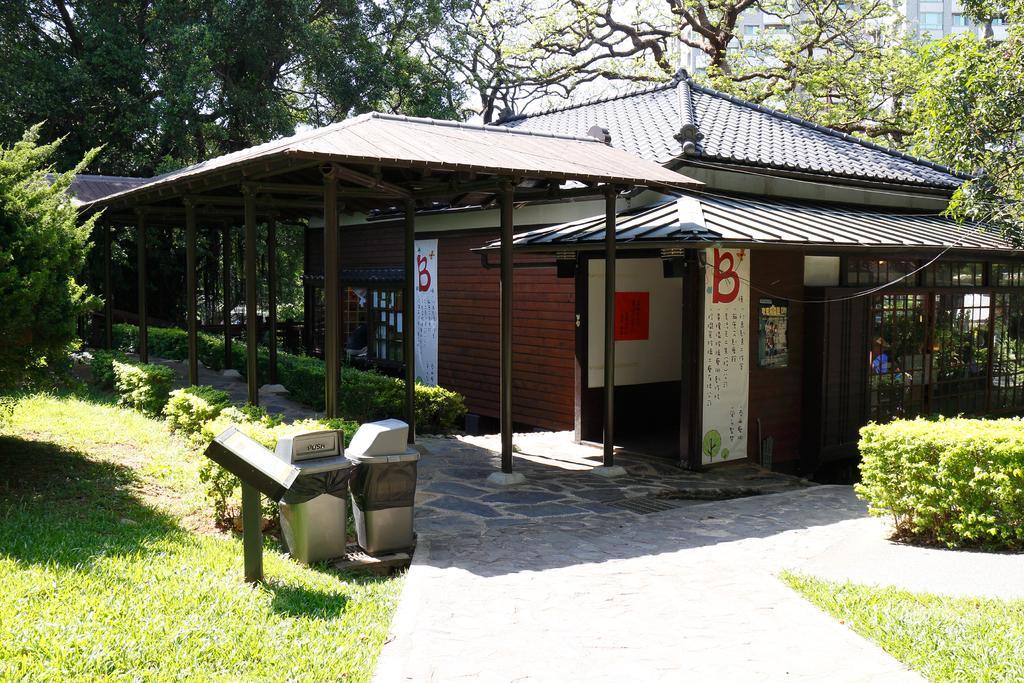Could you give a brief overview of what you see in this image? In this image I can see few buildings, windows, shed, poles, dustbins, few trees and the board is attached to the pole. 